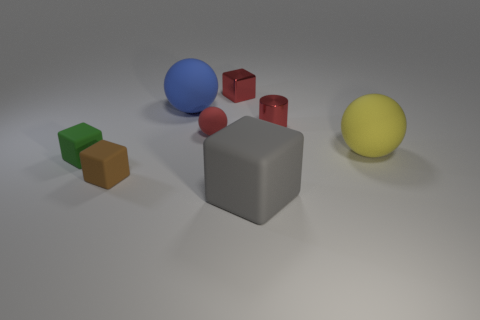There is a metallic cylinder; does it have the same color as the cube behind the yellow sphere?
Keep it short and to the point. Yes. How many objects are either small blocks behind the large yellow matte object or tiny matte objects in front of the yellow thing?
Ensure brevity in your answer.  3. Are there more green blocks behind the yellow matte thing than large yellow rubber objects that are behind the red rubber object?
Ensure brevity in your answer.  No. The small red object in front of the cylinder behind the tiny rubber object that is behind the large yellow sphere is made of what material?
Your answer should be compact. Rubber. There is a large object that is behind the large yellow matte sphere; does it have the same shape as the small rubber object to the right of the big blue object?
Offer a terse response. Yes. Are there any purple metallic objects that have the same size as the brown rubber thing?
Offer a very short reply. No. What number of red things are either rubber objects or tiny cylinders?
Keep it short and to the point. 2. How many small rubber balls have the same color as the tiny shiny cube?
Your response must be concise. 1. How many blocks are red shiny things or tiny matte things?
Your response must be concise. 3. There is a tiny shiny object right of the big gray rubber block; what color is it?
Your answer should be very brief. Red. 